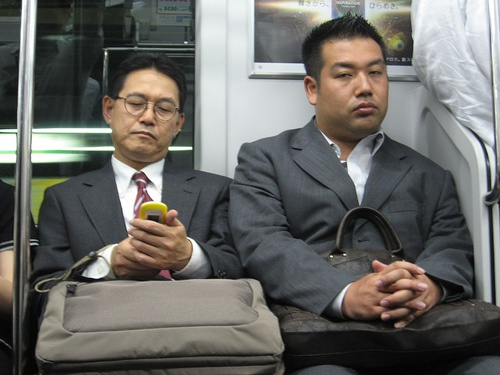Describe the objects in this image and their specific colors. I can see train in black, lightgray, gray, and darkgray tones, people in black, gray, and purple tones, people in black, gray, and white tones, handbag in black, darkgray, and gray tones, and handbag in black and gray tones in this image. 